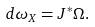<formula> <loc_0><loc_0><loc_500><loc_500>d \omega _ { X } = J ^ { * } \Omega .</formula> 